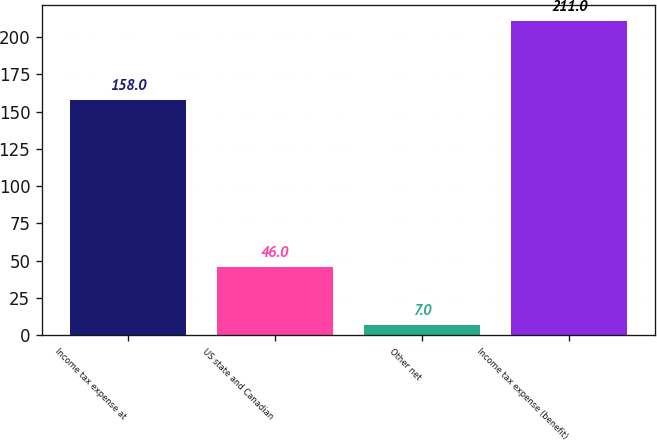Convert chart to OTSL. <chart><loc_0><loc_0><loc_500><loc_500><bar_chart><fcel>Income tax expense at<fcel>US state and Canadian<fcel>Other net<fcel>Income tax expense (benefit)<nl><fcel>158<fcel>46<fcel>7<fcel>211<nl></chart> 